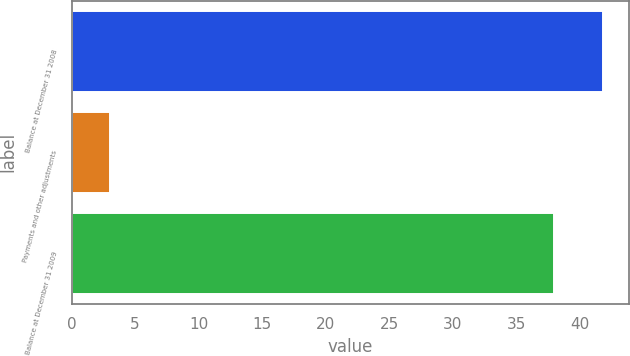Convert chart to OTSL. <chart><loc_0><loc_0><loc_500><loc_500><bar_chart><fcel>Balance at December 31 2008<fcel>Payments and other adjustments<fcel>Balance at December 31 2009<nl><fcel>41.8<fcel>3<fcel>38<nl></chart> 